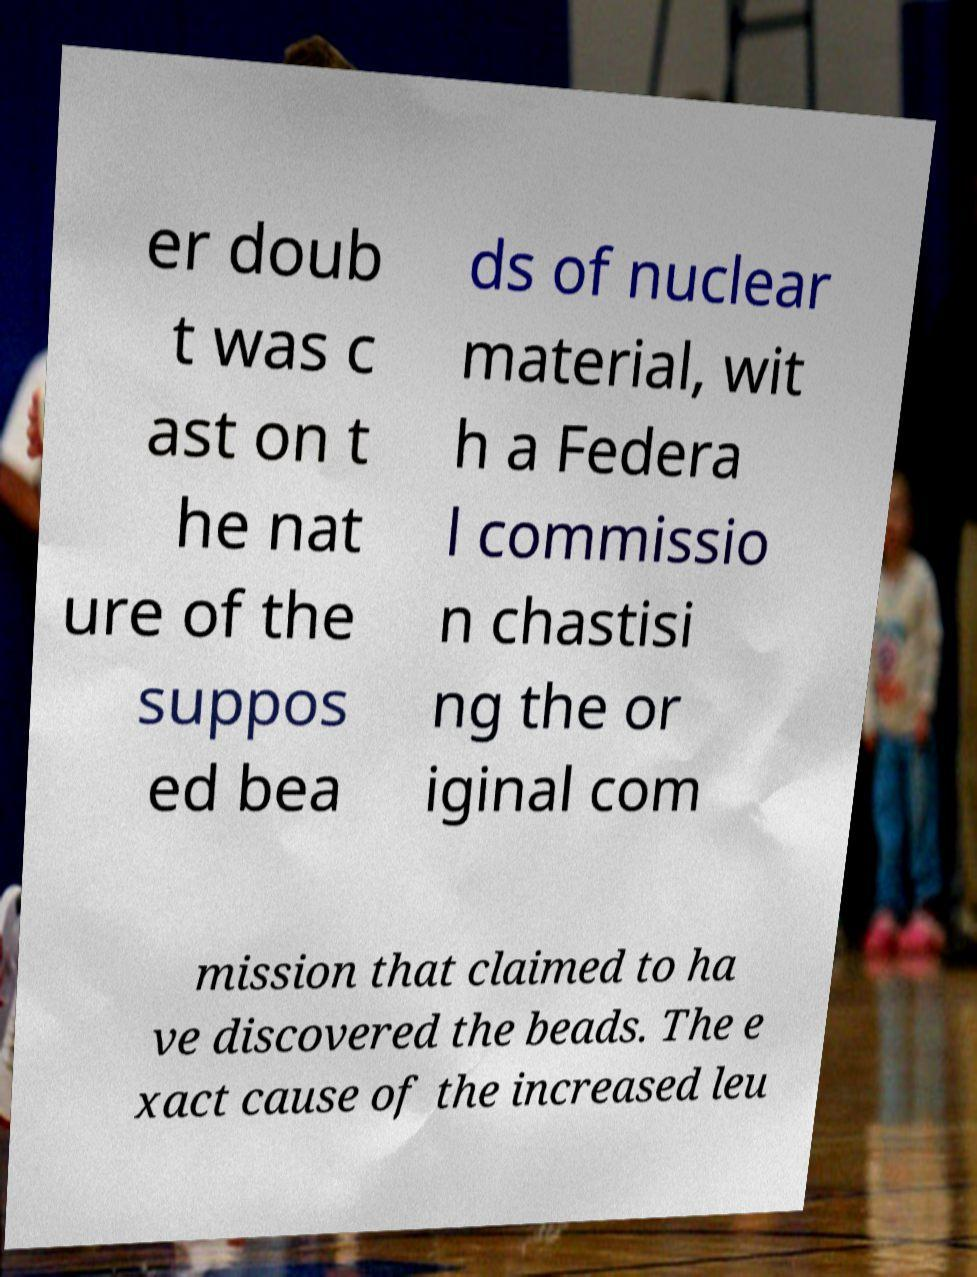Could you extract and type out the text from this image? er doub t was c ast on t he nat ure of the suppos ed bea ds of nuclear material, wit h a Federa l commissio n chastisi ng the or iginal com mission that claimed to ha ve discovered the beads. The e xact cause of the increased leu 